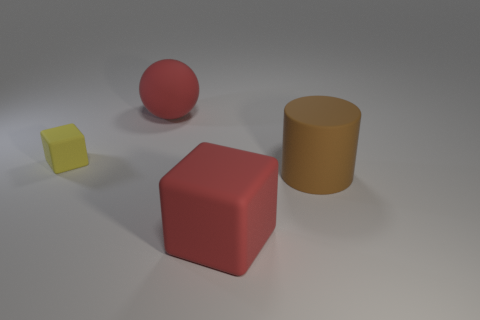How does the lighting affect the perception of the objects? The lighting in the image creates soft shadows and highlights that enhance the three-dimensionality of the objects. It gives depth to the scene and helps to distinguish the textures and colors of the different blocks. The shadows also contribute to the perception of space between the objects, indicating their relative positions to one another. 